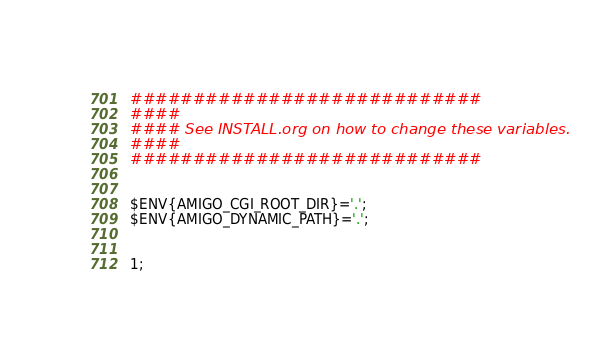Convert code to text. <code><loc_0><loc_0><loc_500><loc_500><_Perl_>############################
####
#### See INSTALL.org on how to change these variables.
####
############################


$ENV{AMIGO_CGI_ROOT_DIR}='.';
$ENV{AMIGO_DYNAMIC_PATH}='.';


1;

</code> 